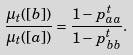Convert formula to latex. <formula><loc_0><loc_0><loc_500><loc_500>\frac { \mu _ { t } ( [ b ] ) } { \mu _ { t } ( [ a ] ) } = \frac { 1 - p _ { a a } ^ { t } } { 1 - p _ { b b } ^ { t } } .</formula> 